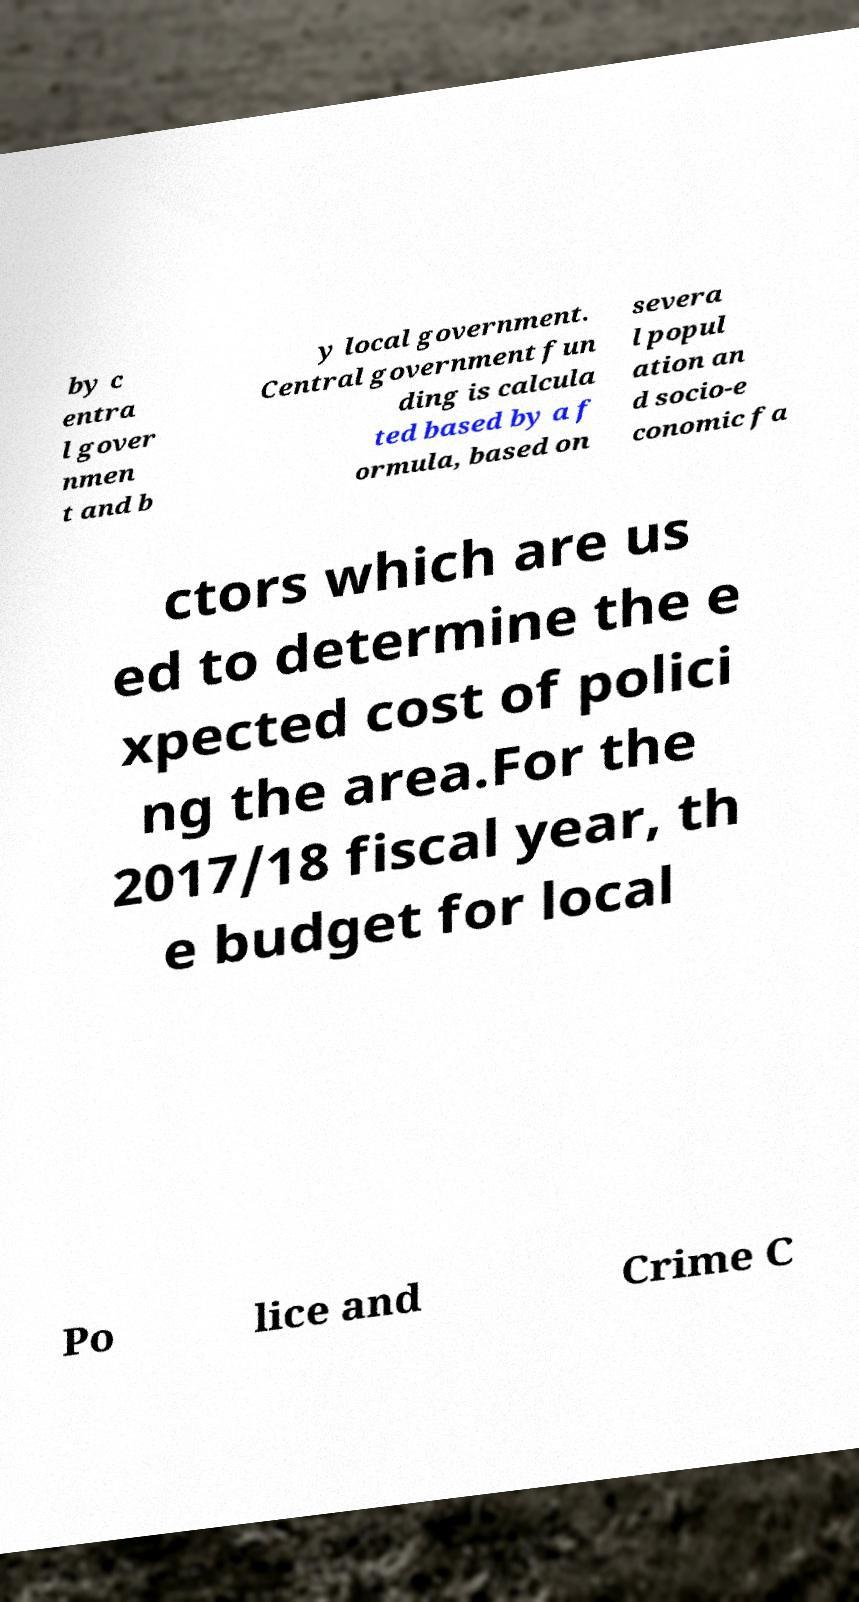I need the written content from this picture converted into text. Can you do that? by c entra l gover nmen t and b y local government. Central government fun ding is calcula ted based by a f ormula, based on severa l popul ation an d socio-e conomic fa ctors which are us ed to determine the e xpected cost of polici ng the area.For the 2017/18 fiscal year, th e budget for local Po lice and Crime C 